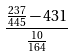Convert formula to latex. <formula><loc_0><loc_0><loc_500><loc_500>\frac { \frac { 2 3 7 } { 4 4 5 } - 4 3 1 } { \frac { 1 0 } { 1 6 4 } }</formula> 